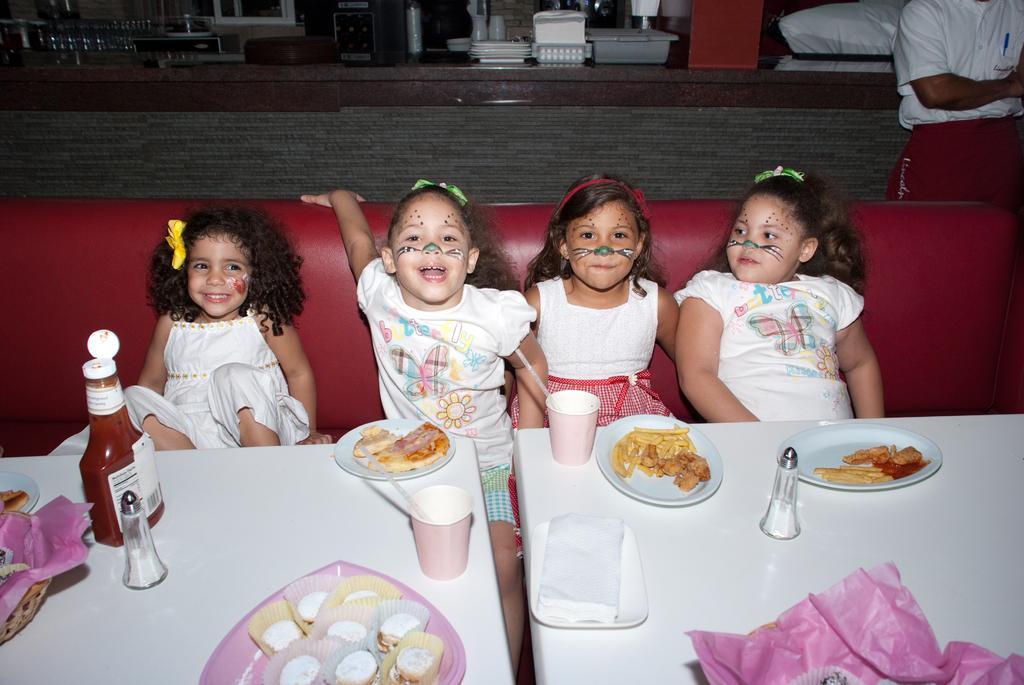In one or two sentences, can you explain what this image depicts? There are four girl kids sitting on sofa and there is a food served in plates in front of them. 